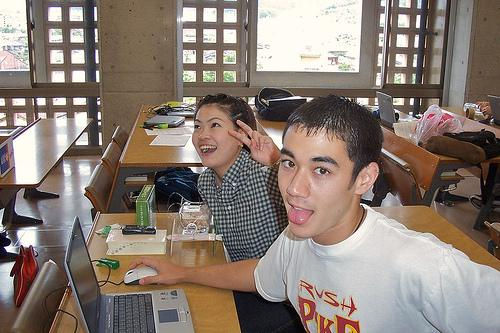List the electronic devices and their respective colors found in the image. There's a tan laptop with black keys, a white computer mouse with a black spot, and a cell phone on a book. Identify the different types of objects placed on the desk and their main purposes. Objects on the desk include a laptop for computing, a computer mouse for navigation, a green pack of gum for fresh breath, and a thick book for studying or reading. Provide a general description of the objects found in the image. The image features two people sitting at a desk with a laptop, computer mouse, a green pack of gum, a red bag on the floor, a black backpack, a white bag with pink clothing, and a window in the wall. Describe the behavior of the two people in the image in a playful manner. A young man cheekily sticks his tongue out while a young girl throws up the peace sign with a beaming smile. Can you count the total number of bags in the image and their colors? There are three bags: a red bag on the floor, a black backpack, and a white plastic bag with pink clothing. What is the condition of the window and how does it affect the image? The window is open, letting in bright sunlight that adds a warm and inviting ambiance to the scene. Describe the contents of the red marking on the man's white tee shirt. The red marking consists of the word "Rush" printed in red alongside other red and yellow words. In a creative manner, describe the scene taking place in the image. Amidst a cozy study session, two quirky students share a lighthearted moment while surrounded by their electronic gadgets, bags, and other personal belongings. What humorous expression does the young man display? The young man has a humorous expression with his orange tongue hanging out of his mouth. What are the colors and patterns found on the girl's shirt? The girl's shirt is blue and white checkered with collar buttons. Does the girl have a curly blonde hair? No, it's not mentioned in the image. 